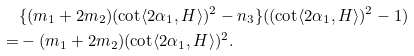<formula> <loc_0><loc_0><loc_500><loc_500>& \{ ( m _ { 1 } + 2 m _ { 2 } ) ( \cot \langle 2 \alpha _ { 1 } , H \rangle ) ^ { 2 } - n _ { 3 } \} ( ( \cot \langle 2 \alpha _ { 1 } , H \rangle ) ^ { 2 } - 1 ) \\ = & - ( m _ { 1 } + 2 m _ { 2 } ) ( \cot \langle 2 \alpha _ { 1 } , H \rangle ) ^ { 2 } .</formula> 